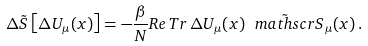<formula> <loc_0><loc_0><loc_500><loc_500>\Delta \tilde { S } \left [ \Delta U _ { \mu } ( x ) \right ] = - \frac { \beta } { N } R e \, T r \, \Delta U _ { \mu } ( x ) \tilde { \ m a t h s c r { S } } _ { \mu } ( x ) \, .</formula> 